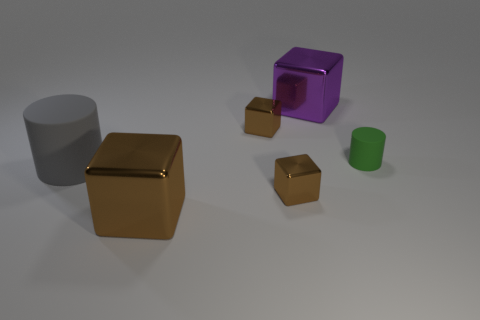Do the large cube on the right side of the big brown object and the cylinder to the right of the large gray object have the same material?
Provide a succinct answer. No. What is the shape of the big thing that is to the right of the big gray matte cylinder and in front of the green rubber thing?
Ensure brevity in your answer.  Cube. What is the color of the large object that is both behind the big brown metal object and on the right side of the big rubber thing?
Your answer should be very brief. Purple. Is the number of large purple shiny things that are right of the big gray cylinder greater than the number of big purple metallic things in front of the green matte cylinder?
Your response must be concise. Yes. There is a tiny block in front of the gray rubber cylinder; what is its color?
Your answer should be very brief. Brown. Do the tiny metallic thing in front of the green rubber object and the rubber object to the left of the tiny rubber thing have the same shape?
Your answer should be very brief. No. Is there a metallic object that has the same size as the purple block?
Keep it short and to the point. Yes. There is a cylinder to the right of the big matte object; what is its material?
Offer a very short reply. Rubber. Do the cylinder that is to the left of the purple metal object and the green cylinder have the same material?
Provide a succinct answer. Yes. Are there any brown objects?
Offer a terse response. Yes. 